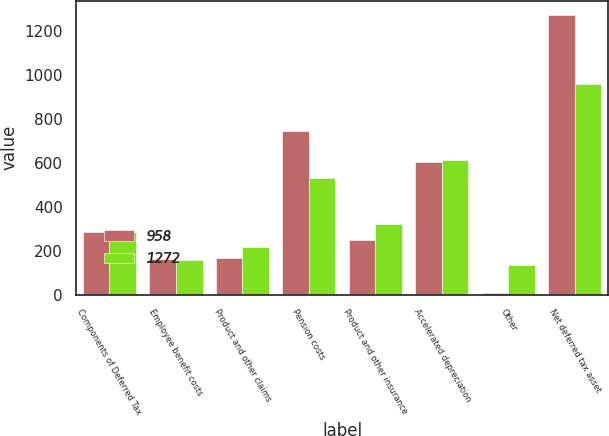<chart> <loc_0><loc_0><loc_500><loc_500><stacked_bar_chart><ecel><fcel>Components of Deferred Tax<fcel>Employee benefit costs<fcel>Product and other claims<fcel>Pension costs<fcel>Product and other insurance<fcel>Accelerated depreciation<fcel>Other<fcel>Net deferred tax asset<nl><fcel>958<fcel>286.5<fcel>163<fcel>167<fcel>742<fcel>250<fcel>601<fcel>9<fcel>1272<nl><fcel>1272<fcel>286.5<fcel>157<fcel>219<fcel>530<fcel>323<fcel>614<fcel>133<fcel>958<nl></chart> 